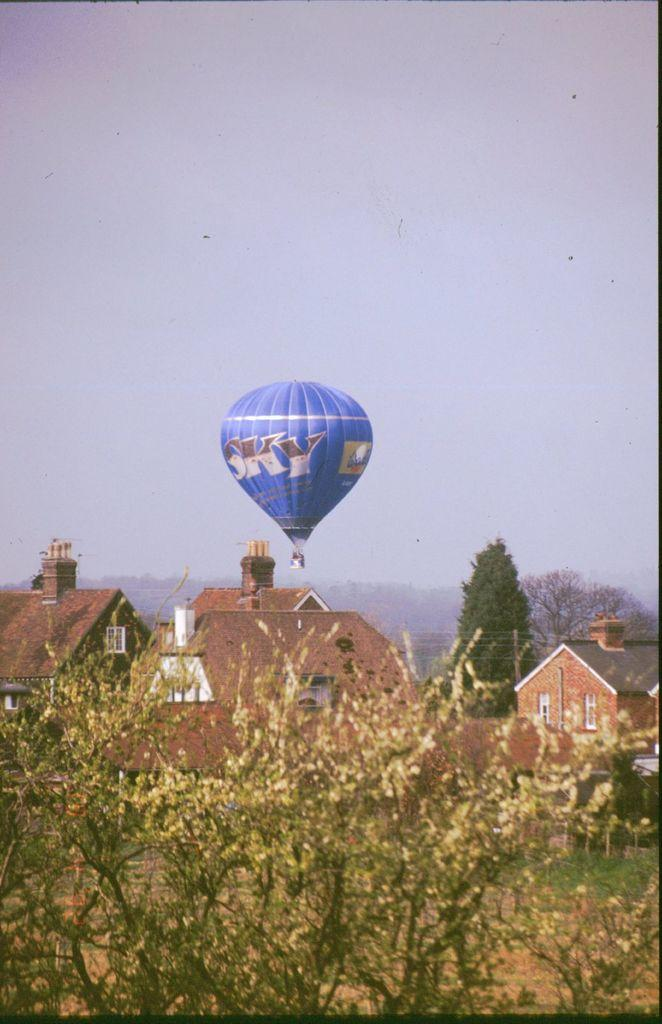What is flying in the image? There is a parachute flying in the image. What type of structures can be seen in the image? There are houses visible in the image. What type of vegetation is present in the image? There are trees in the image. What is visible at the top of the image? The sky is visible at the top of the image. Where is the mountain located in the image? There is no mountain present in the image. What type of bath can be seen in the image? There is no bath present in the image. 